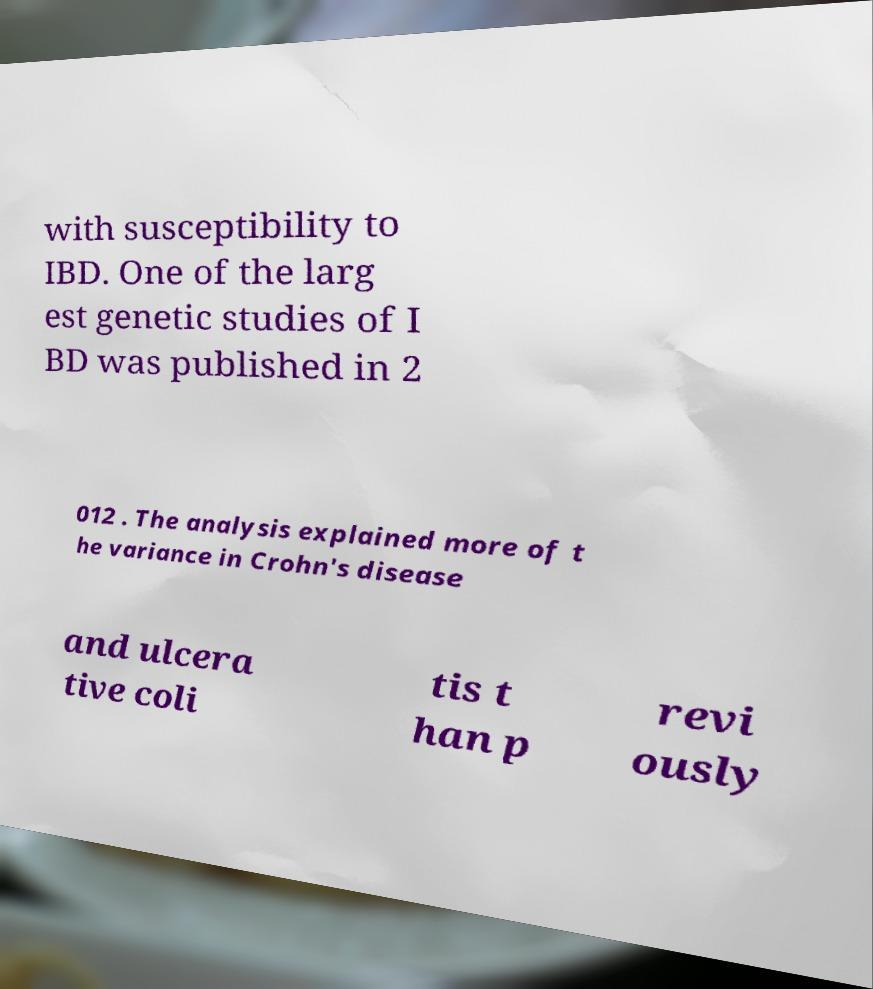I need the written content from this picture converted into text. Can you do that? with susceptibility to IBD. One of the larg est genetic studies of I BD was published in 2 012 . The analysis explained more of t he variance in Crohn's disease and ulcera tive coli tis t han p revi ously 